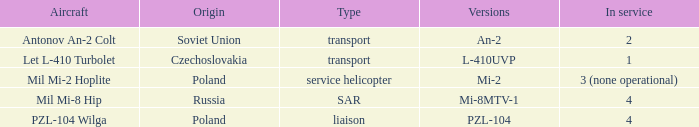Tell me the service for versions l-410uvp 1.0. 